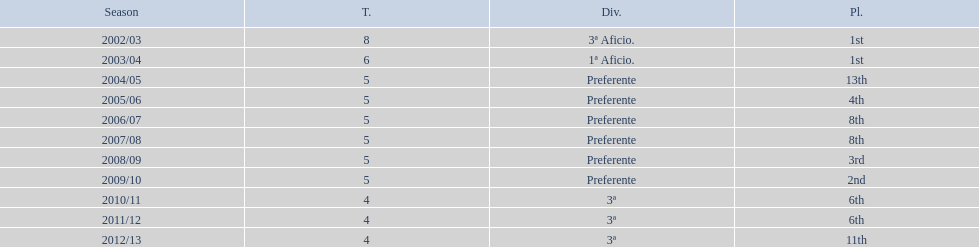Which division has the largest number of ranks? Preferente. 